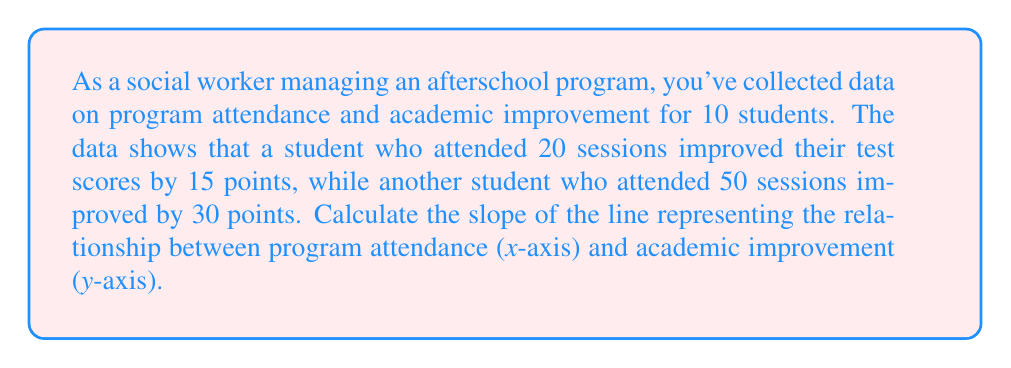Can you answer this question? To calculate the slope of the line, we'll use the slope formula:

$$ m = \frac{y_2 - y_1}{x_2 - x_1} $$

Where:
- $(x_1, y_1)$ is the first point (20 sessions, 15 points improvement)
- $(x_2, y_2)$ is the second point (50 sessions, 30 points improvement)

Let's plug in the values:

$$ m = \frac{30 - 15}{50 - 20} $$

$$ m = \frac{15}{30} $$

Simplify the fraction:

$$ m = \frac{1}{2} = 0.5 $$

This slope indicates that for every additional session attended, there is an average increase of 0.5 points in academic improvement.

Interpretation for social workers:
A positive slope (0.5) suggests a positive correlation between program attendance and academic improvement. This information can be valuable when advocating for the effectiveness of afterschool programs and seeking additional funding or support.
Answer: The slope of the line is $\frac{1}{2}$ or $0.5$. 